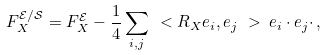Convert formula to latex. <formula><loc_0><loc_0><loc_500><loc_500>F ^ { \mathcal { E } / \mathcal { S } } _ { X } = F ^ { \mathcal { E } } _ { X } - \frac { 1 } { 4 } \sum _ { i , j } \ < R _ { X } e _ { i } , e _ { j } \ > \, e _ { i } \cdot e _ { j } \cdot \, ,</formula> 